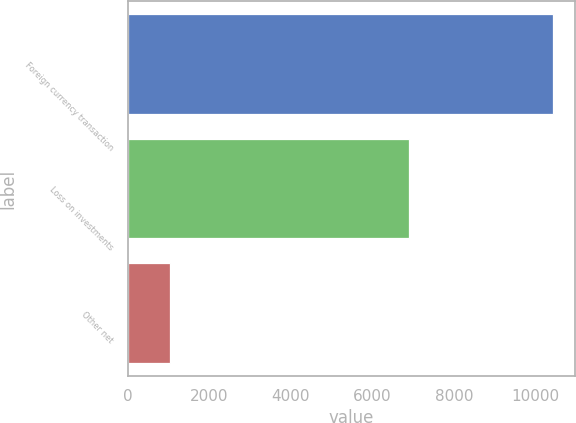Convert chart. <chart><loc_0><loc_0><loc_500><loc_500><bar_chart><fcel>Foreign currency transaction<fcel>Loss on investments<fcel>Other net<nl><fcel>10437<fcel>6900<fcel>1034<nl></chart> 